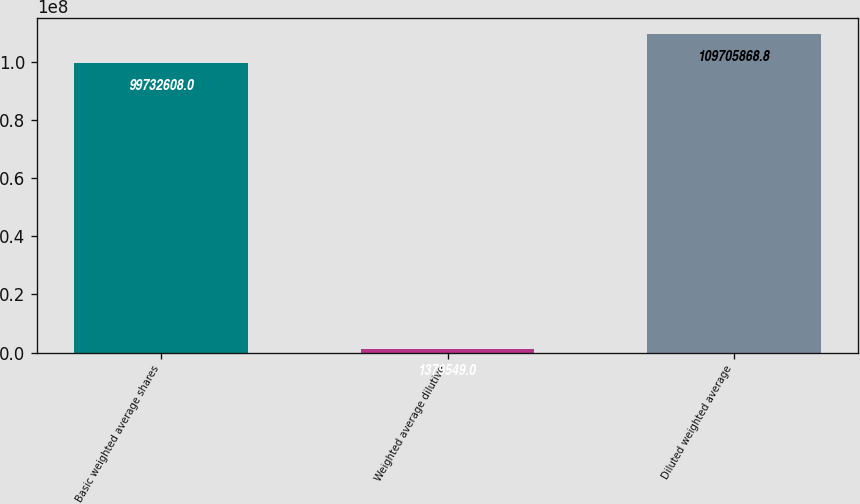<chart> <loc_0><loc_0><loc_500><loc_500><bar_chart><fcel>Basic weighted average shares<fcel>Weighted average dilutive<fcel>Diluted weighted average<nl><fcel>9.97326e+07<fcel>1.37955e+06<fcel>1.09706e+08<nl></chart> 